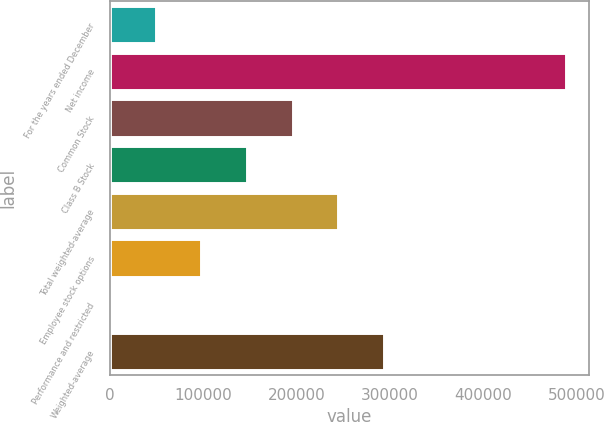Convert chart. <chart><loc_0><loc_0><loc_500><loc_500><bar_chart><fcel>For the years ended December<fcel>Net income<fcel>Common Stock<fcel>Class B Stock<fcel>Total weighted-average<fcel>Employee stock options<fcel>Performance and restricted<fcel>Weighted-average<nl><fcel>49203.9<fcel>488547<fcel>195652<fcel>146836<fcel>244568<fcel>98019.8<fcel>388<fcel>293384<nl></chart> 